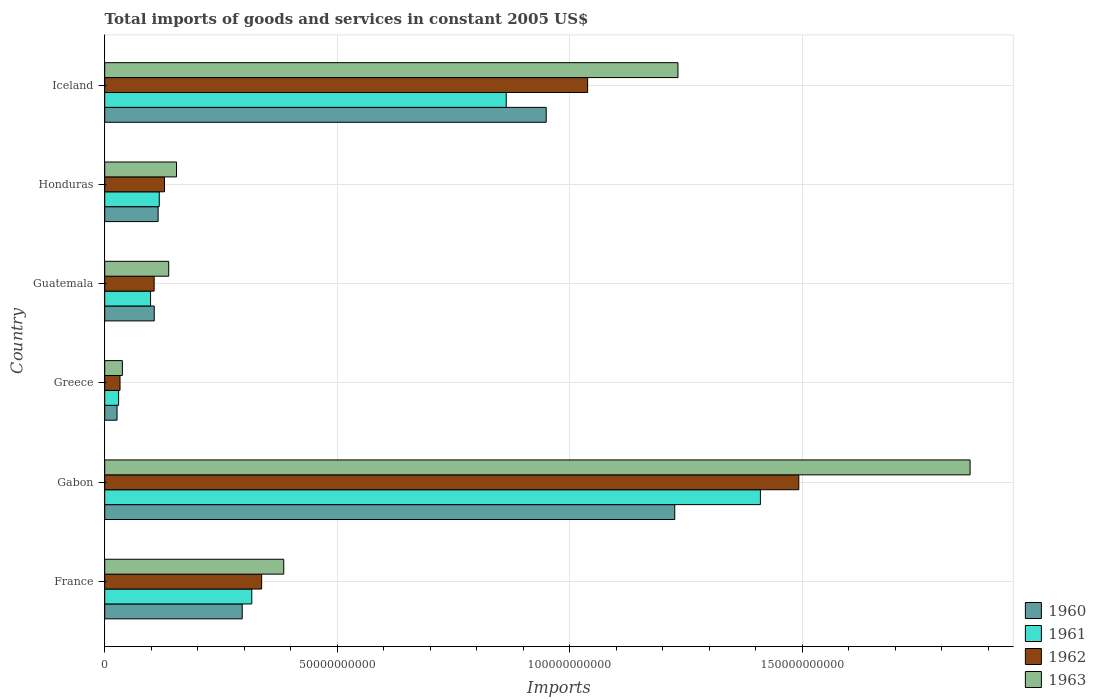How many bars are there on the 6th tick from the top?
Make the answer very short. 4. How many bars are there on the 2nd tick from the bottom?
Your answer should be very brief. 4. What is the label of the 1st group of bars from the top?
Make the answer very short. Iceland. What is the total imports of goods and services in 1962 in Gabon?
Keep it short and to the point. 1.49e+11. Across all countries, what is the maximum total imports of goods and services in 1960?
Keep it short and to the point. 1.23e+11. Across all countries, what is the minimum total imports of goods and services in 1962?
Your answer should be compact. 3.29e+09. In which country was the total imports of goods and services in 1962 maximum?
Offer a terse response. Gabon. In which country was the total imports of goods and services in 1963 minimum?
Give a very brief answer. Greece. What is the total total imports of goods and services in 1961 in the graph?
Your response must be concise. 2.84e+11. What is the difference between the total imports of goods and services in 1963 in Greece and that in Guatemala?
Your response must be concise. -9.96e+09. What is the difference between the total imports of goods and services in 1961 in France and the total imports of goods and services in 1962 in Honduras?
Provide a succinct answer. 1.88e+1. What is the average total imports of goods and services in 1962 per country?
Keep it short and to the point. 5.23e+1. What is the difference between the total imports of goods and services in 1962 and total imports of goods and services in 1960 in Guatemala?
Keep it short and to the point. -2.58e+07. In how many countries, is the total imports of goods and services in 1961 greater than 90000000000 US$?
Provide a succinct answer. 1. What is the ratio of the total imports of goods and services in 1962 in Greece to that in Iceland?
Make the answer very short. 0.03. Is the total imports of goods and services in 1961 in Gabon less than that in Greece?
Your answer should be compact. No. What is the difference between the highest and the second highest total imports of goods and services in 1960?
Your answer should be compact. 2.76e+1. What is the difference between the highest and the lowest total imports of goods and services in 1960?
Offer a very short reply. 1.20e+11. In how many countries, is the total imports of goods and services in 1963 greater than the average total imports of goods and services in 1963 taken over all countries?
Keep it short and to the point. 2. Is it the case that in every country, the sum of the total imports of goods and services in 1960 and total imports of goods and services in 1963 is greater than the sum of total imports of goods and services in 1962 and total imports of goods and services in 1961?
Make the answer very short. No. What does the 1st bar from the bottom in Gabon represents?
Ensure brevity in your answer.  1960. How many bars are there?
Your answer should be very brief. 24. How many countries are there in the graph?
Give a very brief answer. 6. What is the difference between two consecutive major ticks on the X-axis?
Provide a short and direct response. 5.00e+1. Where does the legend appear in the graph?
Make the answer very short. Bottom right. How many legend labels are there?
Offer a terse response. 4. How are the legend labels stacked?
Provide a succinct answer. Vertical. What is the title of the graph?
Provide a short and direct response. Total imports of goods and services in constant 2005 US$. Does "1972" appear as one of the legend labels in the graph?
Provide a succinct answer. No. What is the label or title of the X-axis?
Ensure brevity in your answer.  Imports. What is the label or title of the Y-axis?
Ensure brevity in your answer.  Country. What is the Imports of 1960 in France?
Offer a very short reply. 2.96e+1. What is the Imports of 1961 in France?
Your answer should be very brief. 3.16e+1. What is the Imports of 1962 in France?
Offer a terse response. 3.37e+1. What is the Imports in 1963 in France?
Ensure brevity in your answer.  3.85e+1. What is the Imports of 1960 in Gabon?
Provide a short and direct response. 1.23e+11. What is the Imports in 1961 in Gabon?
Keep it short and to the point. 1.41e+11. What is the Imports of 1962 in Gabon?
Your answer should be very brief. 1.49e+11. What is the Imports of 1963 in Gabon?
Provide a short and direct response. 1.86e+11. What is the Imports in 1960 in Greece?
Your answer should be very brief. 2.65e+09. What is the Imports in 1961 in Greece?
Your response must be concise. 2.99e+09. What is the Imports in 1962 in Greece?
Your answer should be compact. 3.29e+09. What is the Imports in 1963 in Greece?
Make the answer very short. 3.80e+09. What is the Imports in 1960 in Guatemala?
Provide a succinct answer. 1.07e+1. What is the Imports in 1961 in Guatemala?
Ensure brevity in your answer.  9.86e+09. What is the Imports of 1962 in Guatemala?
Keep it short and to the point. 1.06e+1. What is the Imports of 1963 in Guatemala?
Offer a terse response. 1.38e+1. What is the Imports of 1960 in Honduras?
Give a very brief answer. 1.15e+1. What is the Imports in 1961 in Honduras?
Your response must be concise. 1.17e+1. What is the Imports in 1962 in Honduras?
Give a very brief answer. 1.29e+1. What is the Imports in 1963 in Honduras?
Your answer should be compact. 1.54e+1. What is the Imports in 1960 in Iceland?
Your answer should be compact. 9.49e+1. What is the Imports in 1961 in Iceland?
Provide a short and direct response. 8.63e+1. What is the Imports of 1962 in Iceland?
Your answer should be compact. 1.04e+11. What is the Imports in 1963 in Iceland?
Ensure brevity in your answer.  1.23e+11. Across all countries, what is the maximum Imports in 1960?
Ensure brevity in your answer.  1.23e+11. Across all countries, what is the maximum Imports in 1961?
Offer a very short reply. 1.41e+11. Across all countries, what is the maximum Imports in 1962?
Give a very brief answer. 1.49e+11. Across all countries, what is the maximum Imports in 1963?
Keep it short and to the point. 1.86e+11. Across all countries, what is the minimum Imports in 1960?
Your answer should be very brief. 2.65e+09. Across all countries, what is the minimum Imports of 1961?
Ensure brevity in your answer.  2.99e+09. Across all countries, what is the minimum Imports of 1962?
Make the answer very short. 3.29e+09. Across all countries, what is the minimum Imports of 1963?
Your response must be concise. 3.80e+09. What is the total Imports in 1960 in the graph?
Offer a very short reply. 2.72e+11. What is the total Imports in 1961 in the graph?
Give a very brief answer. 2.84e+11. What is the total Imports in 1962 in the graph?
Your answer should be compact. 3.14e+11. What is the total Imports in 1963 in the graph?
Offer a very short reply. 3.81e+11. What is the difference between the Imports in 1960 in France and that in Gabon?
Your response must be concise. -9.30e+1. What is the difference between the Imports in 1961 in France and that in Gabon?
Your answer should be very brief. -1.09e+11. What is the difference between the Imports of 1962 in France and that in Gabon?
Your answer should be compact. -1.16e+11. What is the difference between the Imports of 1963 in France and that in Gabon?
Provide a succinct answer. -1.48e+11. What is the difference between the Imports in 1960 in France and that in Greece?
Provide a succinct answer. 2.69e+1. What is the difference between the Imports in 1961 in France and that in Greece?
Offer a very short reply. 2.86e+1. What is the difference between the Imports of 1962 in France and that in Greece?
Make the answer very short. 3.05e+1. What is the difference between the Imports in 1963 in France and that in Greece?
Your answer should be compact. 3.47e+1. What is the difference between the Imports of 1960 in France and that in Guatemala?
Your response must be concise. 1.89e+1. What is the difference between the Imports of 1961 in France and that in Guatemala?
Give a very brief answer. 2.18e+1. What is the difference between the Imports in 1962 in France and that in Guatemala?
Your answer should be compact. 2.31e+1. What is the difference between the Imports of 1963 in France and that in Guatemala?
Your answer should be compact. 2.47e+1. What is the difference between the Imports of 1960 in France and that in Honduras?
Ensure brevity in your answer.  1.81e+1. What is the difference between the Imports of 1961 in France and that in Honduras?
Your answer should be compact. 1.99e+1. What is the difference between the Imports of 1962 in France and that in Honduras?
Provide a short and direct response. 2.09e+1. What is the difference between the Imports of 1963 in France and that in Honduras?
Your answer should be very brief. 2.31e+1. What is the difference between the Imports in 1960 in France and that in Iceland?
Provide a short and direct response. -6.54e+1. What is the difference between the Imports in 1961 in France and that in Iceland?
Ensure brevity in your answer.  -5.47e+1. What is the difference between the Imports in 1962 in France and that in Iceland?
Offer a terse response. -7.01e+1. What is the difference between the Imports of 1963 in France and that in Iceland?
Ensure brevity in your answer.  -8.48e+1. What is the difference between the Imports in 1960 in Gabon and that in Greece?
Your answer should be very brief. 1.20e+11. What is the difference between the Imports of 1961 in Gabon and that in Greece?
Give a very brief answer. 1.38e+11. What is the difference between the Imports in 1962 in Gabon and that in Greece?
Ensure brevity in your answer.  1.46e+11. What is the difference between the Imports in 1963 in Gabon and that in Greece?
Your response must be concise. 1.82e+11. What is the difference between the Imports in 1960 in Gabon and that in Guatemala?
Offer a terse response. 1.12e+11. What is the difference between the Imports in 1961 in Gabon and that in Guatemala?
Provide a short and direct response. 1.31e+11. What is the difference between the Imports of 1962 in Gabon and that in Guatemala?
Provide a succinct answer. 1.39e+11. What is the difference between the Imports in 1963 in Gabon and that in Guatemala?
Your answer should be very brief. 1.72e+11. What is the difference between the Imports in 1960 in Gabon and that in Honduras?
Offer a very short reply. 1.11e+11. What is the difference between the Imports of 1961 in Gabon and that in Honduras?
Give a very brief answer. 1.29e+11. What is the difference between the Imports in 1962 in Gabon and that in Honduras?
Make the answer very short. 1.36e+11. What is the difference between the Imports in 1963 in Gabon and that in Honduras?
Provide a short and direct response. 1.71e+11. What is the difference between the Imports in 1960 in Gabon and that in Iceland?
Make the answer very short. 2.76e+1. What is the difference between the Imports of 1961 in Gabon and that in Iceland?
Provide a short and direct response. 5.47e+1. What is the difference between the Imports of 1962 in Gabon and that in Iceland?
Keep it short and to the point. 4.54e+1. What is the difference between the Imports of 1963 in Gabon and that in Iceland?
Give a very brief answer. 6.28e+1. What is the difference between the Imports in 1960 in Greece and that in Guatemala?
Your answer should be very brief. -8.00e+09. What is the difference between the Imports of 1961 in Greece and that in Guatemala?
Your answer should be compact. -6.87e+09. What is the difference between the Imports of 1962 in Greece and that in Guatemala?
Offer a very short reply. -7.34e+09. What is the difference between the Imports in 1963 in Greece and that in Guatemala?
Your response must be concise. -9.96e+09. What is the difference between the Imports of 1960 in Greece and that in Honduras?
Keep it short and to the point. -8.83e+09. What is the difference between the Imports of 1961 in Greece and that in Honduras?
Keep it short and to the point. -8.74e+09. What is the difference between the Imports in 1962 in Greece and that in Honduras?
Make the answer very short. -9.56e+09. What is the difference between the Imports in 1963 in Greece and that in Honduras?
Offer a very short reply. -1.16e+1. What is the difference between the Imports in 1960 in Greece and that in Iceland?
Keep it short and to the point. -9.23e+1. What is the difference between the Imports in 1961 in Greece and that in Iceland?
Offer a terse response. -8.34e+1. What is the difference between the Imports in 1962 in Greece and that in Iceland?
Provide a short and direct response. -1.01e+11. What is the difference between the Imports of 1963 in Greece and that in Iceland?
Your answer should be very brief. -1.19e+11. What is the difference between the Imports of 1960 in Guatemala and that in Honduras?
Provide a short and direct response. -8.33e+08. What is the difference between the Imports in 1961 in Guatemala and that in Honduras?
Keep it short and to the point. -1.87e+09. What is the difference between the Imports of 1962 in Guatemala and that in Honduras?
Your answer should be very brief. -2.23e+09. What is the difference between the Imports of 1963 in Guatemala and that in Honduras?
Your answer should be very brief. -1.68e+09. What is the difference between the Imports of 1960 in Guatemala and that in Iceland?
Your answer should be very brief. -8.43e+1. What is the difference between the Imports of 1961 in Guatemala and that in Iceland?
Provide a succinct answer. -7.65e+1. What is the difference between the Imports in 1962 in Guatemala and that in Iceland?
Provide a short and direct response. -9.32e+1. What is the difference between the Imports in 1963 in Guatemala and that in Iceland?
Provide a succinct answer. -1.10e+11. What is the difference between the Imports of 1960 in Honduras and that in Iceland?
Your answer should be compact. -8.34e+1. What is the difference between the Imports of 1961 in Honduras and that in Iceland?
Keep it short and to the point. -7.46e+1. What is the difference between the Imports of 1962 in Honduras and that in Iceland?
Your answer should be compact. -9.10e+1. What is the difference between the Imports in 1963 in Honduras and that in Iceland?
Your response must be concise. -1.08e+11. What is the difference between the Imports of 1960 in France and the Imports of 1961 in Gabon?
Ensure brevity in your answer.  -1.11e+11. What is the difference between the Imports of 1960 in France and the Imports of 1962 in Gabon?
Your answer should be compact. -1.20e+11. What is the difference between the Imports of 1960 in France and the Imports of 1963 in Gabon?
Make the answer very short. -1.57e+11. What is the difference between the Imports of 1961 in France and the Imports of 1962 in Gabon?
Provide a succinct answer. -1.18e+11. What is the difference between the Imports in 1961 in France and the Imports in 1963 in Gabon?
Your answer should be compact. -1.54e+11. What is the difference between the Imports in 1962 in France and the Imports in 1963 in Gabon?
Ensure brevity in your answer.  -1.52e+11. What is the difference between the Imports of 1960 in France and the Imports of 1961 in Greece?
Your answer should be very brief. 2.66e+1. What is the difference between the Imports in 1960 in France and the Imports in 1962 in Greece?
Provide a succinct answer. 2.63e+1. What is the difference between the Imports of 1960 in France and the Imports of 1963 in Greece?
Your answer should be very brief. 2.58e+1. What is the difference between the Imports in 1961 in France and the Imports in 1962 in Greece?
Your answer should be compact. 2.83e+1. What is the difference between the Imports in 1961 in France and the Imports in 1963 in Greece?
Provide a short and direct response. 2.78e+1. What is the difference between the Imports in 1962 in France and the Imports in 1963 in Greece?
Offer a very short reply. 2.99e+1. What is the difference between the Imports of 1960 in France and the Imports of 1961 in Guatemala?
Give a very brief answer. 1.97e+1. What is the difference between the Imports of 1960 in France and the Imports of 1962 in Guatemala?
Ensure brevity in your answer.  1.89e+1. What is the difference between the Imports in 1960 in France and the Imports in 1963 in Guatemala?
Offer a terse response. 1.58e+1. What is the difference between the Imports in 1961 in France and the Imports in 1962 in Guatemala?
Give a very brief answer. 2.10e+1. What is the difference between the Imports in 1961 in France and the Imports in 1963 in Guatemala?
Your answer should be very brief. 1.79e+1. What is the difference between the Imports of 1962 in France and the Imports of 1963 in Guatemala?
Offer a terse response. 2.00e+1. What is the difference between the Imports of 1960 in France and the Imports of 1961 in Honduras?
Your answer should be very brief. 1.78e+1. What is the difference between the Imports in 1960 in France and the Imports in 1962 in Honduras?
Ensure brevity in your answer.  1.67e+1. What is the difference between the Imports of 1960 in France and the Imports of 1963 in Honduras?
Offer a terse response. 1.41e+1. What is the difference between the Imports in 1961 in France and the Imports in 1962 in Honduras?
Your answer should be very brief. 1.88e+1. What is the difference between the Imports in 1961 in France and the Imports in 1963 in Honduras?
Provide a succinct answer. 1.62e+1. What is the difference between the Imports in 1962 in France and the Imports in 1963 in Honduras?
Ensure brevity in your answer.  1.83e+1. What is the difference between the Imports in 1960 in France and the Imports in 1961 in Iceland?
Your answer should be compact. -5.68e+1. What is the difference between the Imports of 1960 in France and the Imports of 1962 in Iceland?
Ensure brevity in your answer.  -7.43e+1. What is the difference between the Imports in 1960 in France and the Imports in 1963 in Iceland?
Keep it short and to the point. -9.37e+1. What is the difference between the Imports of 1961 in France and the Imports of 1962 in Iceland?
Make the answer very short. -7.22e+1. What is the difference between the Imports in 1961 in France and the Imports in 1963 in Iceland?
Keep it short and to the point. -9.16e+1. What is the difference between the Imports of 1962 in France and the Imports of 1963 in Iceland?
Your answer should be compact. -8.95e+1. What is the difference between the Imports in 1960 in Gabon and the Imports in 1961 in Greece?
Provide a succinct answer. 1.20e+11. What is the difference between the Imports in 1960 in Gabon and the Imports in 1962 in Greece?
Provide a succinct answer. 1.19e+11. What is the difference between the Imports of 1960 in Gabon and the Imports of 1963 in Greece?
Provide a succinct answer. 1.19e+11. What is the difference between the Imports of 1961 in Gabon and the Imports of 1962 in Greece?
Offer a terse response. 1.38e+11. What is the difference between the Imports of 1961 in Gabon and the Imports of 1963 in Greece?
Provide a succinct answer. 1.37e+11. What is the difference between the Imports in 1962 in Gabon and the Imports in 1963 in Greece?
Offer a terse response. 1.45e+11. What is the difference between the Imports of 1960 in Gabon and the Imports of 1961 in Guatemala?
Your response must be concise. 1.13e+11. What is the difference between the Imports in 1960 in Gabon and the Imports in 1962 in Guatemala?
Offer a terse response. 1.12e+11. What is the difference between the Imports of 1960 in Gabon and the Imports of 1963 in Guatemala?
Your answer should be very brief. 1.09e+11. What is the difference between the Imports of 1961 in Gabon and the Imports of 1962 in Guatemala?
Ensure brevity in your answer.  1.30e+11. What is the difference between the Imports of 1961 in Gabon and the Imports of 1963 in Guatemala?
Make the answer very short. 1.27e+11. What is the difference between the Imports of 1962 in Gabon and the Imports of 1963 in Guatemala?
Offer a terse response. 1.35e+11. What is the difference between the Imports of 1960 in Gabon and the Imports of 1961 in Honduras?
Give a very brief answer. 1.11e+11. What is the difference between the Imports of 1960 in Gabon and the Imports of 1962 in Honduras?
Provide a succinct answer. 1.10e+11. What is the difference between the Imports of 1960 in Gabon and the Imports of 1963 in Honduras?
Offer a very short reply. 1.07e+11. What is the difference between the Imports in 1961 in Gabon and the Imports in 1962 in Honduras?
Make the answer very short. 1.28e+11. What is the difference between the Imports in 1961 in Gabon and the Imports in 1963 in Honduras?
Your response must be concise. 1.26e+11. What is the difference between the Imports in 1962 in Gabon and the Imports in 1963 in Honduras?
Make the answer very short. 1.34e+11. What is the difference between the Imports in 1960 in Gabon and the Imports in 1961 in Iceland?
Your answer should be very brief. 3.62e+1. What is the difference between the Imports of 1960 in Gabon and the Imports of 1962 in Iceland?
Ensure brevity in your answer.  1.87e+1. What is the difference between the Imports in 1960 in Gabon and the Imports in 1963 in Iceland?
Offer a very short reply. -6.90e+08. What is the difference between the Imports of 1961 in Gabon and the Imports of 1962 in Iceland?
Ensure brevity in your answer.  3.71e+1. What is the difference between the Imports of 1961 in Gabon and the Imports of 1963 in Iceland?
Offer a very short reply. 1.77e+1. What is the difference between the Imports in 1962 in Gabon and the Imports in 1963 in Iceland?
Your answer should be compact. 2.60e+1. What is the difference between the Imports in 1960 in Greece and the Imports in 1961 in Guatemala?
Offer a terse response. -7.21e+09. What is the difference between the Imports in 1960 in Greece and the Imports in 1962 in Guatemala?
Offer a terse response. -7.97e+09. What is the difference between the Imports of 1960 in Greece and the Imports of 1963 in Guatemala?
Your answer should be very brief. -1.11e+1. What is the difference between the Imports of 1961 in Greece and the Imports of 1962 in Guatemala?
Offer a very short reply. -7.64e+09. What is the difference between the Imports in 1961 in Greece and the Imports in 1963 in Guatemala?
Ensure brevity in your answer.  -1.08e+1. What is the difference between the Imports in 1962 in Greece and the Imports in 1963 in Guatemala?
Offer a very short reply. -1.05e+1. What is the difference between the Imports of 1960 in Greece and the Imports of 1961 in Honduras?
Keep it short and to the point. -9.08e+09. What is the difference between the Imports in 1960 in Greece and the Imports in 1962 in Honduras?
Provide a short and direct response. -1.02e+1. What is the difference between the Imports of 1960 in Greece and the Imports of 1963 in Honduras?
Your response must be concise. -1.28e+1. What is the difference between the Imports in 1961 in Greece and the Imports in 1962 in Honduras?
Your answer should be compact. -9.86e+09. What is the difference between the Imports in 1961 in Greece and the Imports in 1963 in Honduras?
Give a very brief answer. -1.24e+1. What is the difference between the Imports of 1962 in Greece and the Imports of 1963 in Honduras?
Your response must be concise. -1.21e+1. What is the difference between the Imports of 1960 in Greece and the Imports of 1961 in Iceland?
Offer a terse response. -8.37e+1. What is the difference between the Imports in 1960 in Greece and the Imports in 1962 in Iceland?
Keep it short and to the point. -1.01e+11. What is the difference between the Imports in 1960 in Greece and the Imports in 1963 in Iceland?
Make the answer very short. -1.21e+11. What is the difference between the Imports in 1961 in Greece and the Imports in 1962 in Iceland?
Ensure brevity in your answer.  -1.01e+11. What is the difference between the Imports of 1961 in Greece and the Imports of 1963 in Iceland?
Give a very brief answer. -1.20e+11. What is the difference between the Imports in 1962 in Greece and the Imports in 1963 in Iceland?
Keep it short and to the point. -1.20e+11. What is the difference between the Imports of 1960 in Guatemala and the Imports of 1961 in Honduras?
Your answer should be very brief. -1.08e+09. What is the difference between the Imports in 1960 in Guatemala and the Imports in 1962 in Honduras?
Provide a short and direct response. -2.20e+09. What is the difference between the Imports of 1960 in Guatemala and the Imports of 1963 in Honduras?
Give a very brief answer. -4.78e+09. What is the difference between the Imports in 1961 in Guatemala and the Imports in 1962 in Honduras?
Provide a succinct answer. -2.99e+09. What is the difference between the Imports of 1961 in Guatemala and the Imports of 1963 in Honduras?
Provide a succinct answer. -5.58e+09. What is the difference between the Imports of 1962 in Guatemala and the Imports of 1963 in Honduras?
Offer a terse response. -4.81e+09. What is the difference between the Imports of 1960 in Guatemala and the Imports of 1961 in Iceland?
Give a very brief answer. -7.57e+1. What is the difference between the Imports of 1960 in Guatemala and the Imports of 1962 in Iceland?
Your answer should be compact. -9.32e+1. What is the difference between the Imports of 1960 in Guatemala and the Imports of 1963 in Iceland?
Give a very brief answer. -1.13e+11. What is the difference between the Imports in 1961 in Guatemala and the Imports in 1962 in Iceland?
Make the answer very short. -9.40e+1. What is the difference between the Imports in 1961 in Guatemala and the Imports in 1963 in Iceland?
Make the answer very short. -1.13e+11. What is the difference between the Imports of 1962 in Guatemala and the Imports of 1963 in Iceland?
Your answer should be very brief. -1.13e+11. What is the difference between the Imports of 1960 in Honduras and the Imports of 1961 in Iceland?
Offer a terse response. -7.49e+1. What is the difference between the Imports in 1960 in Honduras and the Imports in 1962 in Iceland?
Offer a terse response. -9.24e+1. What is the difference between the Imports in 1960 in Honduras and the Imports in 1963 in Iceland?
Your answer should be very brief. -1.12e+11. What is the difference between the Imports of 1961 in Honduras and the Imports of 1962 in Iceland?
Your answer should be very brief. -9.21e+1. What is the difference between the Imports in 1961 in Honduras and the Imports in 1963 in Iceland?
Offer a terse response. -1.12e+11. What is the difference between the Imports of 1962 in Honduras and the Imports of 1963 in Iceland?
Ensure brevity in your answer.  -1.10e+11. What is the average Imports in 1960 per country?
Make the answer very short. 4.53e+1. What is the average Imports in 1961 per country?
Your answer should be very brief. 4.73e+1. What is the average Imports of 1962 per country?
Keep it short and to the point. 5.23e+1. What is the average Imports of 1963 per country?
Your response must be concise. 6.35e+1. What is the difference between the Imports in 1960 and Imports in 1961 in France?
Offer a terse response. -2.05e+09. What is the difference between the Imports of 1960 and Imports of 1962 in France?
Give a very brief answer. -4.17e+09. What is the difference between the Imports in 1960 and Imports in 1963 in France?
Your answer should be very brief. -8.93e+09. What is the difference between the Imports in 1961 and Imports in 1962 in France?
Offer a very short reply. -2.12e+09. What is the difference between the Imports of 1961 and Imports of 1963 in France?
Offer a very short reply. -6.88e+09. What is the difference between the Imports in 1962 and Imports in 1963 in France?
Your answer should be very brief. -4.75e+09. What is the difference between the Imports of 1960 and Imports of 1961 in Gabon?
Provide a short and direct response. -1.84e+1. What is the difference between the Imports in 1960 and Imports in 1962 in Gabon?
Keep it short and to the point. -2.67e+1. What is the difference between the Imports of 1960 and Imports of 1963 in Gabon?
Your answer should be very brief. -6.35e+1. What is the difference between the Imports of 1961 and Imports of 1962 in Gabon?
Your answer should be very brief. -8.26e+09. What is the difference between the Imports in 1961 and Imports in 1963 in Gabon?
Make the answer very short. -4.51e+1. What is the difference between the Imports of 1962 and Imports of 1963 in Gabon?
Provide a succinct answer. -3.68e+1. What is the difference between the Imports in 1960 and Imports in 1961 in Greece?
Give a very brief answer. -3.37e+08. What is the difference between the Imports in 1960 and Imports in 1962 in Greece?
Provide a succinct answer. -6.39e+08. What is the difference between the Imports of 1960 and Imports of 1963 in Greece?
Make the answer very short. -1.15e+09. What is the difference between the Imports of 1961 and Imports of 1962 in Greece?
Your answer should be very brief. -3.02e+08. What is the difference between the Imports in 1961 and Imports in 1963 in Greece?
Your response must be concise. -8.09e+08. What is the difference between the Imports in 1962 and Imports in 1963 in Greece?
Your answer should be compact. -5.06e+08. What is the difference between the Imports of 1960 and Imports of 1961 in Guatemala?
Provide a short and direct response. 7.93e+08. What is the difference between the Imports in 1960 and Imports in 1962 in Guatemala?
Give a very brief answer. 2.58e+07. What is the difference between the Imports in 1960 and Imports in 1963 in Guatemala?
Give a very brief answer. -3.11e+09. What is the difference between the Imports of 1961 and Imports of 1962 in Guatemala?
Make the answer very short. -7.67e+08. What is the difference between the Imports of 1961 and Imports of 1963 in Guatemala?
Offer a terse response. -3.90e+09. What is the difference between the Imports of 1962 and Imports of 1963 in Guatemala?
Provide a succinct answer. -3.13e+09. What is the difference between the Imports of 1960 and Imports of 1961 in Honduras?
Provide a short and direct response. -2.44e+08. What is the difference between the Imports in 1960 and Imports in 1962 in Honduras?
Ensure brevity in your answer.  -1.37e+09. What is the difference between the Imports in 1960 and Imports in 1963 in Honduras?
Your response must be concise. -3.95e+09. What is the difference between the Imports in 1961 and Imports in 1962 in Honduras?
Offer a terse response. -1.12e+09. What is the difference between the Imports in 1961 and Imports in 1963 in Honduras?
Ensure brevity in your answer.  -3.71e+09. What is the difference between the Imports of 1962 and Imports of 1963 in Honduras?
Give a very brief answer. -2.58e+09. What is the difference between the Imports of 1960 and Imports of 1961 in Iceland?
Provide a succinct answer. 8.59e+09. What is the difference between the Imports in 1960 and Imports in 1962 in Iceland?
Your response must be concise. -8.91e+09. What is the difference between the Imports of 1960 and Imports of 1963 in Iceland?
Give a very brief answer. -2.83e+1. What is the difference between the Imports in 1961 and Imports in 1962 in Iceland?
Keep it short and to the point. -1.75e+1. What is the difference between the Imports of 1961 and Imports of 1963 in Iceland?
Your response must be concise. -3.69e+1. What is the difference between the Imports in 1962 and Imports in 1963 in Iceland?
Ensure brevity in your answer.  -1.94e+1. What is the ratio of the Imports of 1960 in France to that in Gabon?
Your response must be concise. 0.24. What is the ratio of the Imports of 1961 in France to that in Gabon?
Give a very brief answer. 0.22. What is the ratio of the Imports of 1962 in France to that in Gabon?
Your answer should be very brief. 0.23. What is the ratio of the Imports of 1963 in France to that in Gabon?
Give a very brief answer. 0.21. What is the ratio of the Imports in 1960 in France to that in Greece?
Offer a very short reply. 11.15. What is the ratio of the Imports of 1961 in France to that in Greece?
Provide a short and direct response. 10.58. What is the ratio of the Imports of 1962 in France to that in Greece?
Provide a succinct answer. 10.25. What is the ratio of the Imports in 1963 in France to that in Greece?
Make the answer very short. 10.14. What is the ratio of the Imports of 1960 in France to that in Guatemala?
Make the answer very short. 2.78. What is the ratio of the Imports in 1961 in France to that in Guatemala?
Make the answer very short. 3.21. What is the ratio of the Imports of 1962 in France to that in Guatemala?
Offer a terse response. 3.18. What is the ratio of the Imports of 1963 in France to that in Guatemala?
Provide a short and direct response. 2.8. What is the ratio of the Imports of 1960 in France to that in Honduras?
Provide a short and direct response. 2.57. What is the ratio of the Imports of 1961 in France to that in Honduras?
Give a very brief answer. 2.7. What is the ratio of the Imports of 1962 in France to that in Honduras?
Keep it short and to the point. 2.63. What is the ratio of the Imports in 1963 in France to that in Honduras?
Your response must be concise. 2.49. What is the ratio of the Imports of 1960 in France to that in Iceland?
Make the answer very short. 0.31. What is the ratio of the Imports in 1961 in France to that in Iceland?
Your answer should be compact. 0.37. What is the ratio of the Imports in 1962 in France to that in Iceland?
Make the answer very short. 0.33. What is the ratio of the Imports of 1963 in France to that in Iceland?
Provide a short and direct response. 0.31. What is the ratio of the Imports of 1960 in Gabon to that in Greece?
Your response must be concise. 46.22. What is the ratio of the Imports in 1961 in Gabon to that in Greece?
Make the answer very short. 47.18. What is the ratio of the Imports in 1962 in Gabon to that in Greece?
Your answer should be compact. 45.35. What is the ratio of the Imports of 1963 in Gabon to that in Greece?
Your answer should be compact. 49. What is the ratio of the Imports in 1960 in Gabon to that in Guatemala?
Offer a terse response. 11.51. What is the ratio of the Imports in 1961 in Gabon to that in Guatemala?
Give a very brief answer. 14.3. What is the ratio of the Imports of 1962 in Gabon to that in Guatemala?
Provide a succinct answer. 14.05. What is the ratio of the Imports of 1963 in Gabon to that in Guatemala?
Offer a terse response. 13.52. What is the ratio of the Imports in 1960 in Gabon to that in Honduras?
Your answer should be very brief. 10.67. What is the ratio of the Imports of 1961 in Gabon to that in Honduras?
Keep it short and to the point. 12.02. What is the ratio of the Imports of 1962 in Gabon to that in Honduras?
Provide a short and direct response. 11.61. What is the ratio of the Imports of 1963 in Gabon to that in Honduras?
Offer a very short reply. 12.06. What is the ratio of the Imports of 1960 in Gabon to that in Iceland?
Give a very brief answer. 1.29. What is the ratio of the Imports in 1961 in Gabon to that in Iceland?
Offer a terse response. 1.63. What is the ratio of the Imports of 1962 in Gabon to that in Iceland?
Provide a succinct answer. 1.44. What is the ratio of the Imports in 1963 in Gabon to that in Iceland?
Provide a succinct answer. 1.51. What is the ratio of the Imports of 1960 in Greece to that in Guatemala?
Your response must be concise. 0.25. What is the ratio of the Imports of 1961 in Greece to that in Guatemala?
Ensure brevity in your answer.  0.3. What is the ratio of the Imports of 1962 in Greece to that in Guatemala?
Your answer should be very brief. 0.31. What is the ratio of the Imports in 1963 in Greece to that in Guatemala?
Ensure brevity in your answer.  0.28. What is the ratio of the Imports of 1960 in Greece to that in Honduras?
Offer a terse response. 0.23. What is the ratio of the Imports of 1961 in Greece to that in Honduras?
Your answer should be very brief. 0.25. What is the ratio of the Imports of 1962 in Greece to that in Honduras?
Keep it short and to the point. 0.26. What is the ratio of the Imports of 1963 in Greece to that in Honduras?
Ensure brevity in your answer.  0.25. What is the ratio of the Imports in 1960 in Greece to that in Iceland?
Give a very brief answer. 0.03. What is the ratio of the Imports of 1961 in Greece to that in Iceland?
Keep it short and to the point. 0.03. What is the ratio of the Imports in 1962 in Greece to that in Iceland?
Ensure brevity in your answer.  0.03. What is the ratio of the Imports in 1963 in Greece to that in Iceland?
Ensure brevity in your answer.  0.03. What is the ratio of the Imports in 1960 in Guatemala to that in Honduras?
Your answer should be very brief. 0.93. What is the ratio of the Imports of 1961 in Guatemala to that in Honduras?
Ensure brevity in your answer.  0.84. What is the ratio of the Imports of 1962 in Guatemala to that in Honduras?
Provide a succinct answer. 0.83. What is the ratio of the Imports in 1963 in Guatemala to that in Honduras?
Provide a short and direct response. 0.89. What is the ratio of the Imports in 1960 in Guatemala to that in Iceland?
Your answer should be very brief. 0.11. What is the ratio of the Imports of 1961 in Guatemala to that in Iceland?
Keep it short and to the point. 0.11. What is the ratio of the Imports in 1962 in Guatemala to that in Iceland?
Provide a short and direct response. 0.1. What is the ratio of the Imports in 1963 in Guatemala to that in Iceland?
Your answer should be compact. 0.11. What is the ratio of the Imports of 1960 in Honduras to that in Iceland?
Offer a very short reply. 0.12. What is the ratio of the Imports of 1961 in Honduras to that in Iceland?
Your response must be concise. 0.14. What is the ratio of the Imports in 1962 in Honduras to that in Iceland?
Offer a terse response. 0.12. What is the ratio of the Imports in 1963 in Honduras to that in Iceland?
Keep it short and to the point. 0.13. What is the difference between the highest and the second highest Imports of 1960?
Your answer should be compact. 2.76e+1. What is the difference between the highest and the second highest Imports of 1961?
Your answer should be compact. 5.47e+1. What is the difference between the highest and the second highest Imports in 1962?
Provide a succinct answer. 4.54e+1. What is the difference between the highest and the second highest Imports of 1963?
Your answer should be compact. 6.28e+1. What is the difference between the highest and the lowest Imports of 1960?
Your answer should be very brief. 1.20e+11. What is the difference between the highest and the lowest Imports in 1961?
Your answer should be compact. 1.38e+11. What is the difference between the highest and the lowest Imports of 1962?
Your answer should be compact. 1.46e+11. What is the difference between the highest and the lowest Imports of 1963?
Your response must be concise. 1.82e+11. 